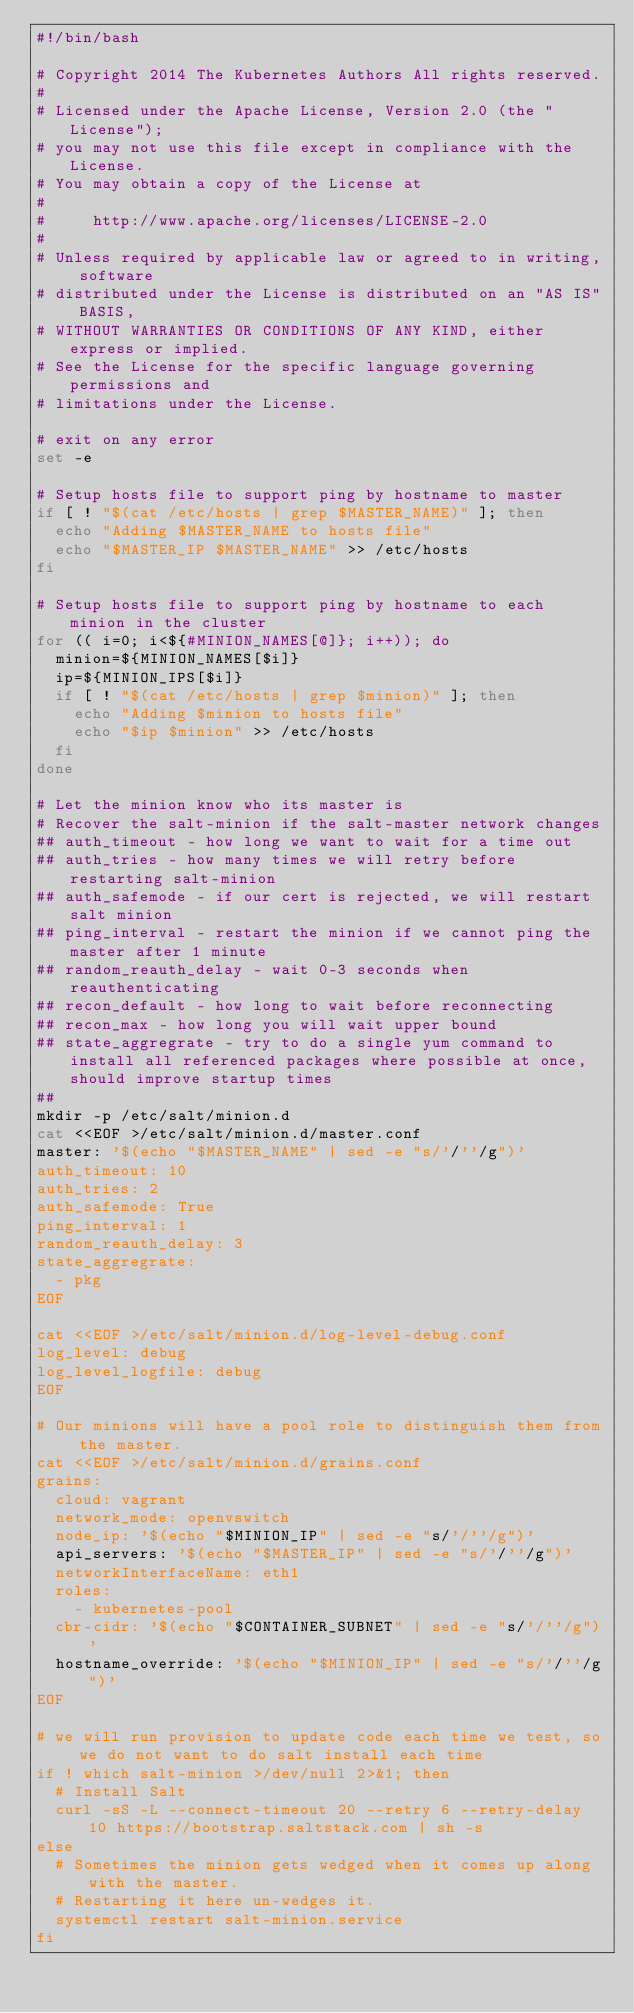Convert code to text. <code><loc_0><loc_0><loc_500><loc_500><_Bash_>#!/bin/bash

# Copyright 2014 The Kubernetes Authors All rights reserved.
#
# Licensed under the Apache License, Version 2.0 (the "License");
# you may not use this file except in compliance with the License.
# You may obtain a copy of the License at
#
#     http://www.apache.org/licenses/LICENSE-2.0
#
# Unless required by applicable law or agreed to in writing, software
# distributed under the License is distributed on an "AS IS" BASIS,
# WITHOUT WARRANTIES OR CONDITIONS OF ANY KIND, either express or implied.
# See the License for the specific language governing permissions and
# limitations under the License.

# exit on any error
set -e

# Setup hosts file to support ping by hostname to master
if [ ! "$(cat /etc/hosts | grep $MASTER_NAME)" ]; then
  echo "Adding $MASTER_NAME to hosts file"
  echo "$MASTER_IP $MASTER_NAME" >> /etc/hosts
fi

# Setup hosts file to support ping by hostname to each minion in the cluster
for (( i=0; i<${#MINION_NAMES[@]}; i++)); do
  minion=${MINION_NAMES[$i]}
  ip=${MINION_IPS[$i]}
  if [ ! "$(cat /etc/hosts | grep $minion)" ]; then
    echo "Adding $minion to hosts file"
    echo "$ip $minion" >> /etc/hosts
  fi
done

# Let the minion know who its master is
# Recover the salt-minion if the salt-master network changes
## auth_timeout - how long we want to wait for a time out
## auth_tries - how many times we will retry before restarting salt-minion
## auth_safemode - if our cert is rejected, we will restart salt minion
## ping_interval - restart the minion if we cannot ping the master after 1 minute
## random_reauth_delay - wait 0-3 seconds when reauthenticating
## recon_default - how long to wait before reconnecting
## recon_max - how long you will wait upper bound
## state_aggregrate - try to do a single yum command to install all referenced packages where possible at once, should improve startup times
##
mkdir -p /etc/salt/minion.d
cat <<EOF >/etc/salt/minion.d/master.conf
master: '$(echo "$MASTER_NAME" | sed -e "s/'/''/g")'
auth_timeout: 10
auth_tries: 2
auth_safemode: True
ping_interval: 1
random_reauth_delay: 3
state_aggregrate:
  - pkg
EOF

cat <<EOF >/etc/salt/minion.d/log-level-debug.conf
log_level: debug
log_level_logfile: debug
EOF

# Our minions will have a pool role to distinguish them from the master.
cat <<EOF >/etc/salt/minion.d/grains.conf
grains:
  cloud: vagrant
  network_mode: openvswitch
  node_ip: '$(echo "$MINION_IP" | sed -e "s/'/''/g")'
  api_servers: '$(echo "$MASTER_IP" | sed -e "s/'/''/g")'
  networkInterfaceName: eth1
  roles:
    - kubernetes-pool
  cbr-cidr: '$(echo "$CONTAINER_SUBNET" | sed -e "s/'/''/g")'
  hostname_override: '$(echo "$MINION_IP" | sed -e "s/'/''/g")'
EOF

# we will run provision to update code each time we test, so we do not want to do salt install each time
if ! which salt-minion >/dev/null 2>&1; then
  # Install Salt
  curl -sS -L --connect-timeout 20 --retry 6 --retry-delay 10 https://bootstrap.saltstack.com | sh -s
else
  # Sometimes the minion gets wedged when it comes up along with the master.
  # Restarting it here un-wedges it.
  systemctl restart salt-minion.service
fi
</code> 